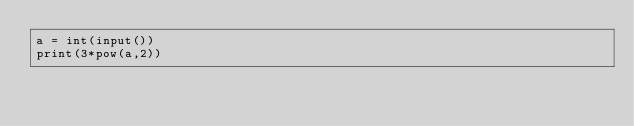<code> <loc_0><loc_0><loc_500><loc_500><_Python_>a = int(input())
print(3*pow(a,2))</code> 